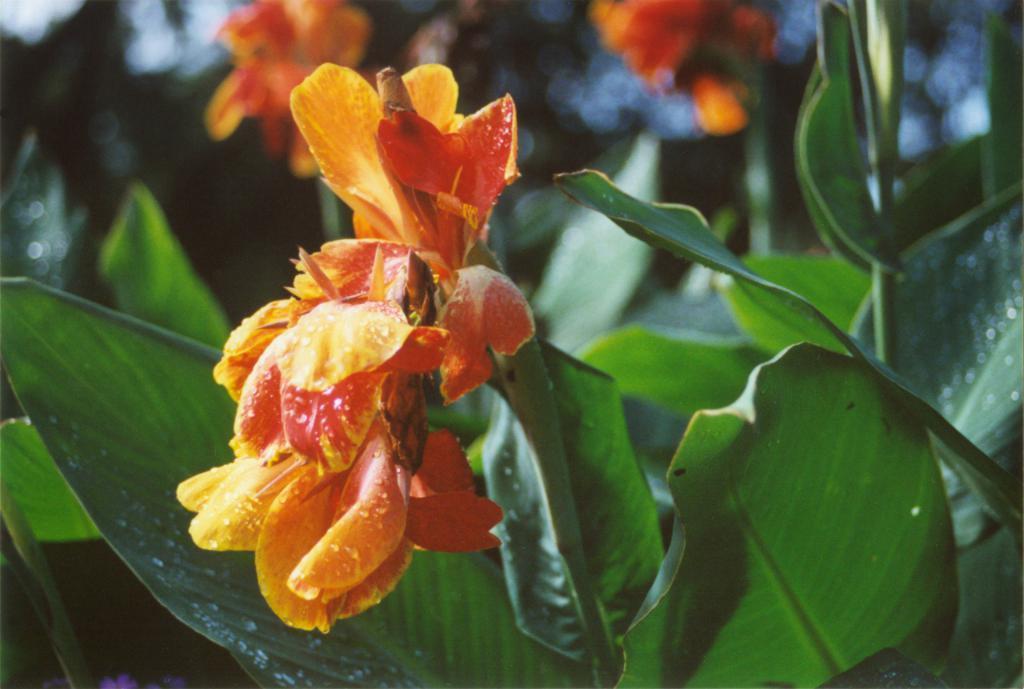Please provide a concise description of this image. In the center of the image we can see plants with flowers. In the background, we can see it is blurred. 